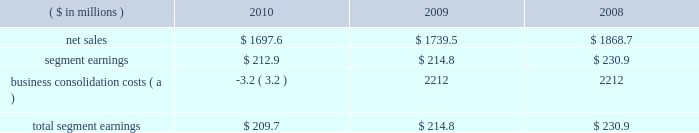Page 20 of 100 segment sales were $ 100.7 million lower in 2009 than in 2008 , primarily as a result of the impact of lower aluminum prices partially offset by an increase in sales volumes .
The higher sales volumes in 2009 were the result of incremental volumes from the four plants purchased from ab inbev , partially offset by certain plant closures and lower sales volumes in the existing business .
Segment earnings in 2010 were $ 122.3 million higher than in 2009 primarily due to a net $ 85 million impact related to the higher sales volumes and $ 45 million of product mix and improved manufacturing performance associated with higher production .
Also adding to the 2010 improvement was the effect of a $ 7 million out-of-period inventory charge in 2009 .
The details of the out-of-period adjustment are included in note 7 to the consolidated financial statements included within item 8 of this report .
Segment earnings in 2009 were higher than in 2008 due to $ 12 million of earnings contribution from the four acquired plants and approximately $ 21 million of savings associated with plant closures .
Partially offsetting these favorable impacts were lower carbonated soft drink and beer can sales volumes ( excluding the newly acquired plants ) and approximately $ 25 million related to higher cost inventories in the first half of 2009 .
Metal beverage packaging , europe .
( a ) further details of these items are included in note 5 to the consolidated financial statements within item 8 of this report .
The metal beverage packaging , europe , segment includes metal beverage packaging products manufactured in europe .
Ball packaging europe has manufacturing plants located in germany , the united kingdom , france , the netherlands , poland and serbia , and is the second largest metal beverage container business in europe .
Segment sales in 2010 decreased $ 41.9 million compared to 2009 , primarily due to unfavorable foreign exchange effects of $ 93 million and price and mix changes , partially offset by higher sales volumes .
Segment sales in 2009 as compared to 2008 were $ 129.2 million lower due to $ 110 million of unfavorable foreign exchange effects , partially offset by better commercial terms .
Sales volumes in 2009 were essentially flat compared to those in the prior year .
Segment earnings in 2010 decreased $ 1.9 million compared to 2009 , primarily the result of a $ 28 million increase related to higher sales volumes , offset by $ 18 million of negative effects from foreign currency translation and $ 12 million of higher inventory and other costs .
While 2009 sales volumes were consistent with the prior year , the adverse effects of foreign currency translation , both within europe and on the conversion of the euro to the u.s .
Dollar , reduced segment earnings by $ 8 million .
Also contributing to lower segment earnings were higher cost inventory carried into 2009 and a change in sales mix , partially offset by better commercial terms in some of our contracts .
On january 18 , 2011 , ball acquired aerocan s.a.s .
( aerocan ) , a leading european supplier of aluminum aerosol cans and bottles , for 20ac222.4 million ( approximately $ 300 million ) in cash and assumed debt .
Aerocan manufactures extruded aluminum aerosol cans and bottles , and the aluminum slugs used to make them , for customers in the personal care , pharmaceutical , beverage and food industries .
It operates three aerosol can manufacturing plants 2013 one each in the czech republic , france and the united kingdom 2013 and is a 51 percent owner of a joint venture aluminum slug plant in france .
The four plants employ approximately 560 people .
The acquisition of aerocan will allow ball to enter a growing part of the metal packaging industry and to broaden the company 2019s market development efforts into a new customer base. .
What was the percentage change in net sales metal beverage packaging , europe between 2009 to 2010? 
Computations: ((1697.6 - 1739.5) / 1739.5)
Answer: -0.02409. 